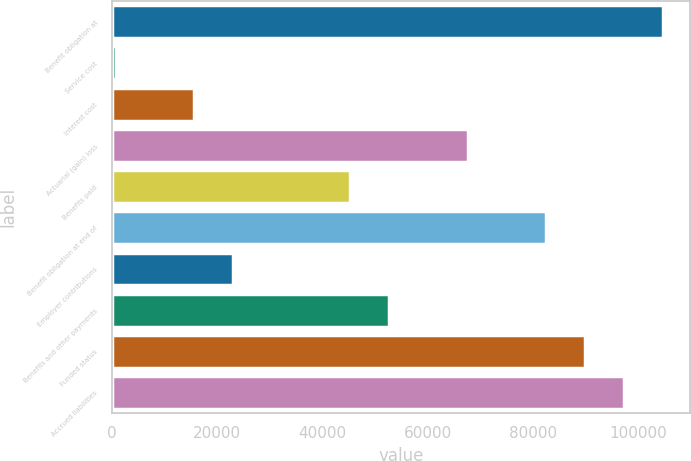<chart> <loc_0><loc_0><loc_500><loc_500><bar_chart><fcel>Benefit obligation at<fcel>Service cost<fcel>Interest cost<fcel>Actuarial (gain) loss<fcel>Benefits paid<fcel>Benefit obligation at end of<fcel>Employer contributions<fcel>Benefits and other payments<fcel>Funded status<fcel>Accrued liabilities<nl><fcel>104656<fcel>742<fcel>15586.8<fcel>67543.6<fcel>45276.4<fcel>82388.4<fcel>23009.2<fcel>52698.8<fcel>89810.8<fcel>97233.2<nl></chart> 